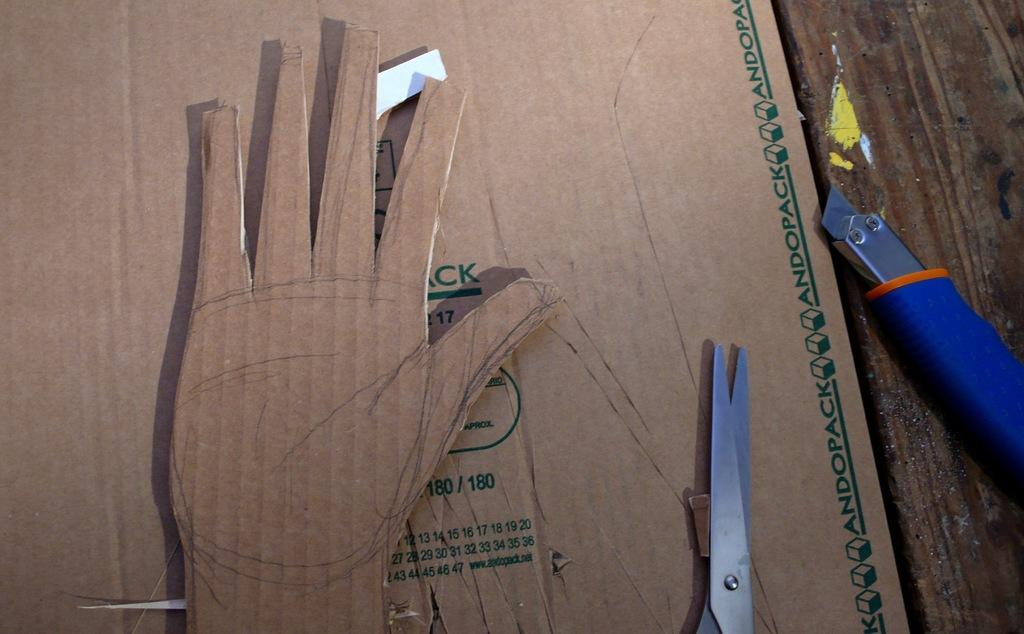What is the main object in the image? There is a cardboard sheet in the image. What shape is the cardboard sheet cut into? The cardboard sheet is cut into a hand shape. What tool is used to cut the cardboard sheet? Scissors are visible in the image. What other cutting tool is present in the image? A blade cutter is present on the wood in the image. What type of yak can be seen grazing in the background of the image? There is no yak present in the image; it features a cardboard sheet cut into a hand shape, scissors, and a blade cutter. 